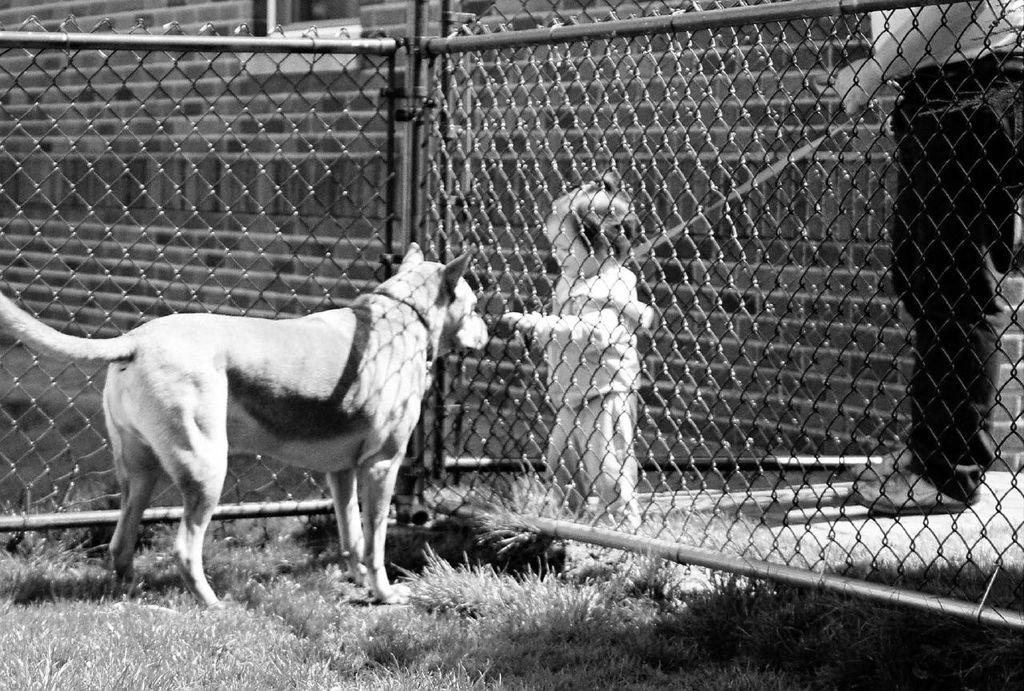What animal is located on the left side of the image? There is a dog on the left side of the image. What type of barrier is present in the image? There is a metal grill fence in the image. Who else can be seen on the right side of the image? There is a kid and a person on the right side of the image. What type of vegetation is visible in the image? There is grass visible in the image. What type of stove is being used by the dog in the image? There is no stove present in the image, and the dog is not using any appliances. How does the person on the right side of the image hear the dog's thoughts? There is no indication in the image that the person can hear the dog's thoughts, and the image does not depict any form of telepathy. 